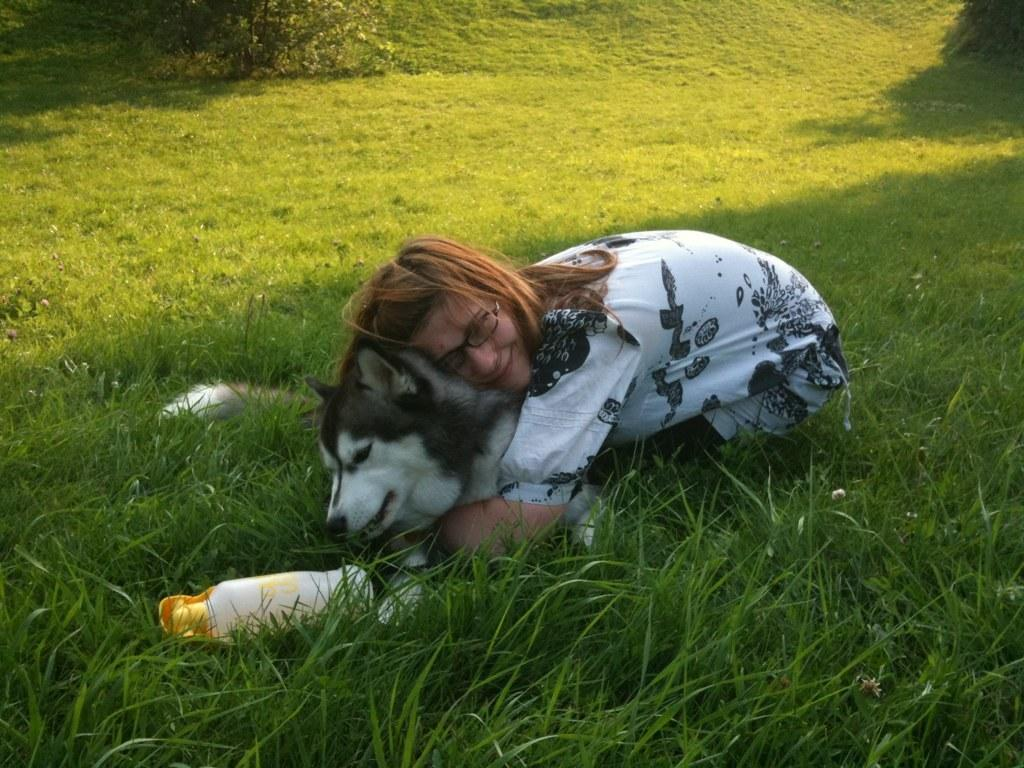Who is in the image? There is a girl in the image. What is the girl doing in the image? The girl is hugging a dog in the image. What type of surface is visible in the image? There is grass in the image. What type of trade is being conducted in the image? There is no trade being conducted in the image; it features a girl hugging a dog on grass. 